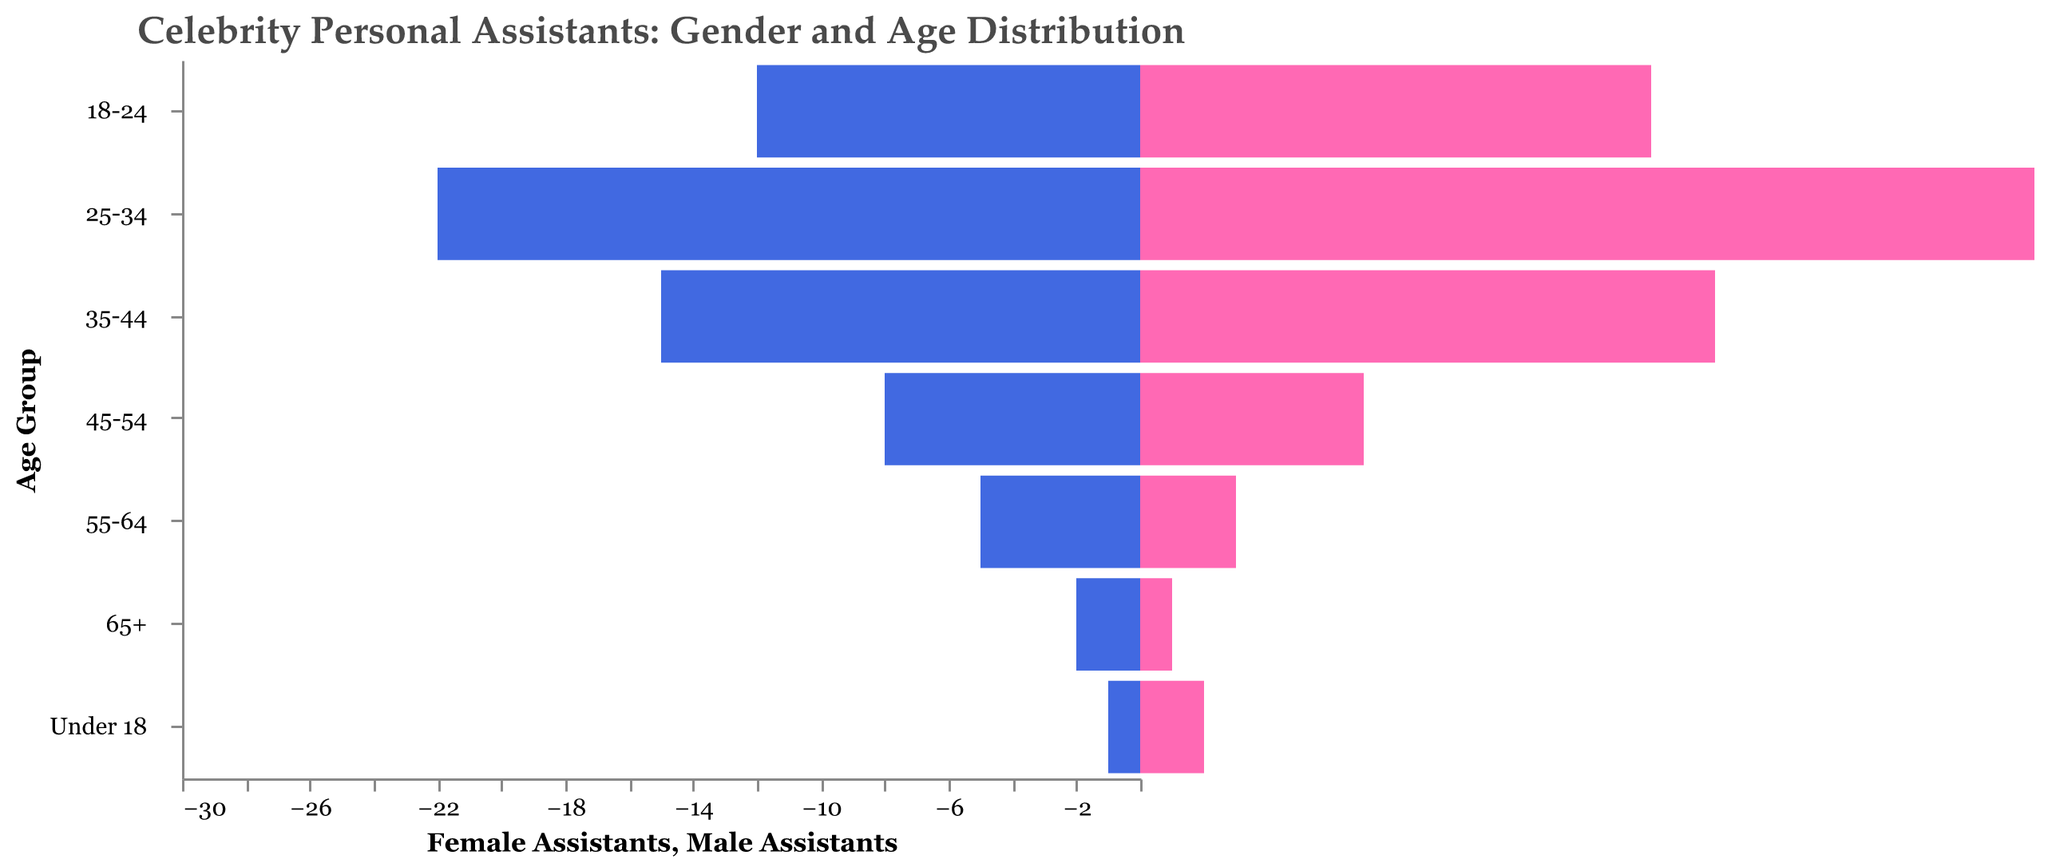What's the title of the figure? The title is usually located at the top of the figure. In this figure, the title is clearly labeled above the data visualization.
Answer: Celebrity Personal Assistants: Gender and Age Distribution Which age group has the highest number of male assistants? To find the age group with the highest number of male assistants, compare the values for all age groups on the left side of the pyramid for the highest negative value.
Answer: 25-34 How many female assistants are aged 35-44? Refer to the bar corresponding to the 35-44 age group on the right side of the pyramid and read the value associated with female assistants.
Answer: 18 Compare the number of male and female assistants in the 18-24 age group. Which is higher? By comparing the bars for both genders in the 18-24 age group, we see that the bar for female assistants is longer.
Answer: Female assistants What's the total number of assistants aged 65+? Add the number of male and female assistants in the 65+ age group. The values are 2 for males and 1 for females.
Answer: 3 Which age group shows a higher count of female assistants compared to male assistants, and by how much? Identify the age group where the female assistants' bar exceeds the male assistants' bar, and then subtract the count of male assistants from female assistants within that age group. For 25-34, there are 28 female and 22 male assistants. 28 - 22 = 6.
Answer: 25-34, 6 Is the number of male assistants aged 45-54 closer to the number of male assistants aged 55-64 or the number of female assistants aged 45-54? For comparison, the counts are: male assistants aged 45-54 is 8, male assistants aged 55-64 is 5, and female assistants aged 45-54 is 7. The closest value to 8 is 7 (female) compared to 5 (male).
Answer: Female assistants aged 45-54 Which is the smallest age group for female assistants? Find the shortest bar on the right side of the pyramid, which corresponds to the age group with the fewest female assistants.
Answer: 65+ Compare the total number of assistants in the 25-34 age group to those in the 18-24 age group. Which age group has more, and by how many? Add the male and female assistants for each age group, then compare the totals. For 25-34: 22 + 28 = 50, and for 18-24: 12 + 16 = 28. 50 - 28 = 22.
Answer: 25-34, 22 